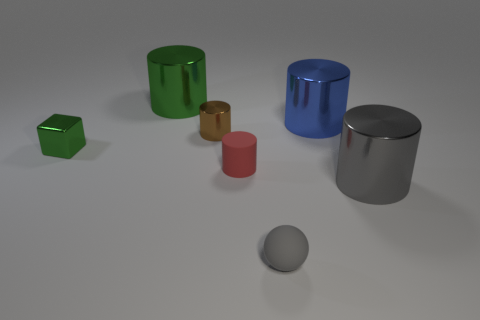What number of things are large objects behind the large gray metallic object or cylinders right of the red cylinder?
Your answer should be compact. 3. The tiny matte object in front of the red rubber thing on the left side of the gray metal thing is what shape?
Provide a succinct answer. Sphere. Are there any other things that are the same color as the sphere?
Provide a short and direct response. Yes. Is there anything else that is the same size as the gray shiny cylinder?
Ensure brevity in your answer.  Yes. How many objects are yellow things or small balls?
Your answer should be compact. 1. Is there a gray object that has the same size as the gray metallic cylinder?
Provide a succinct answer. No. The blue thing has what shape?
Provide a short and direct response. Cylinder. Is the number of blue metallic cylinders that are left of the block greater than the number of brown shiny things that are in front of the tiny gray matte thing?
Make the answer very short. No. Do the matte object that is in front of the gray shiny cylinder and the small cylinder on the left side of the red cylinder have the same color?
Your answer should be compact. No. There is another metallic thing that is the same size as the brown thing; what shape is it?
Your answer should be very brief. Cube. 